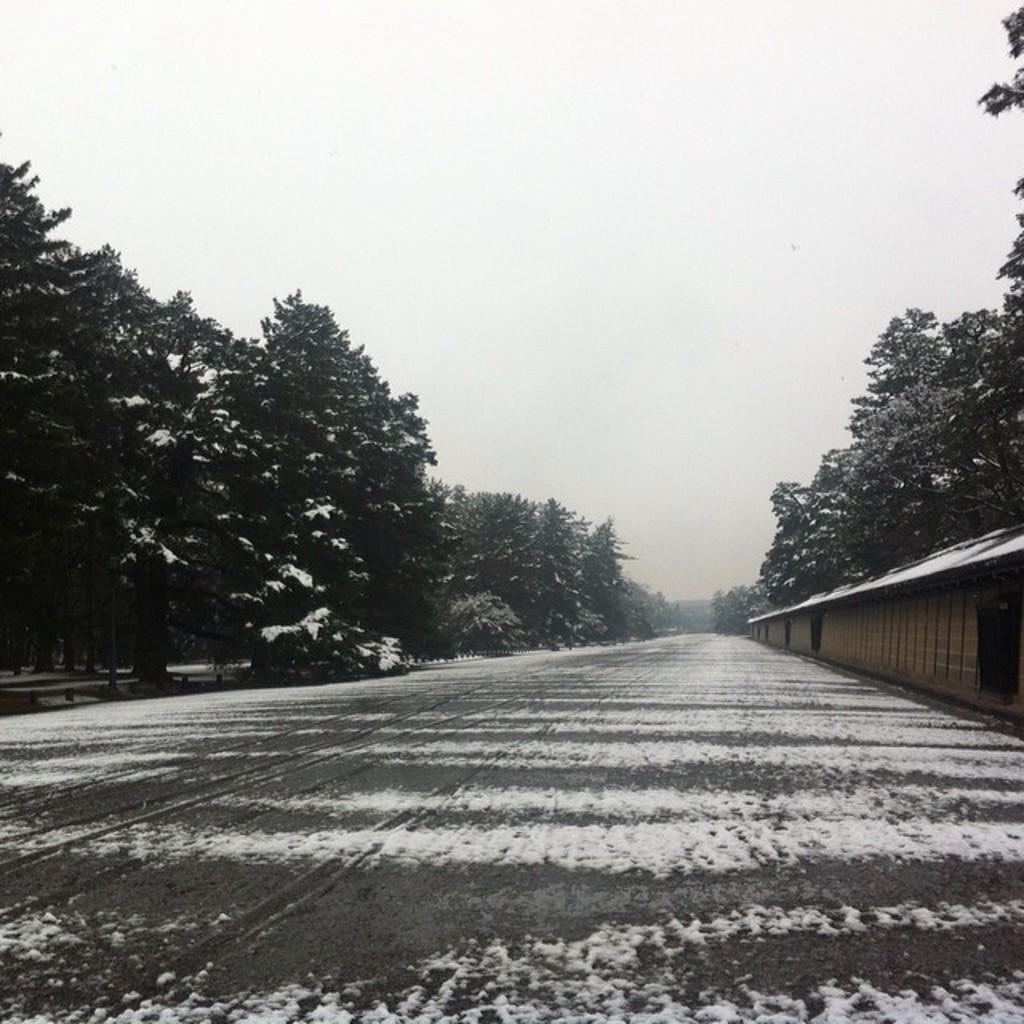What is the color scheme of the image? The image is black and white. What can be seen in the middle of the image? There is a path in the middle of the image. What type of vegetation is present on either side of the path? There are trees on either side of the path. What is visible above the path and trees? The sky is visible above the path and trees. How many babies are holding tomatoes in the image? There are no babies or tomatoes present in the image. 